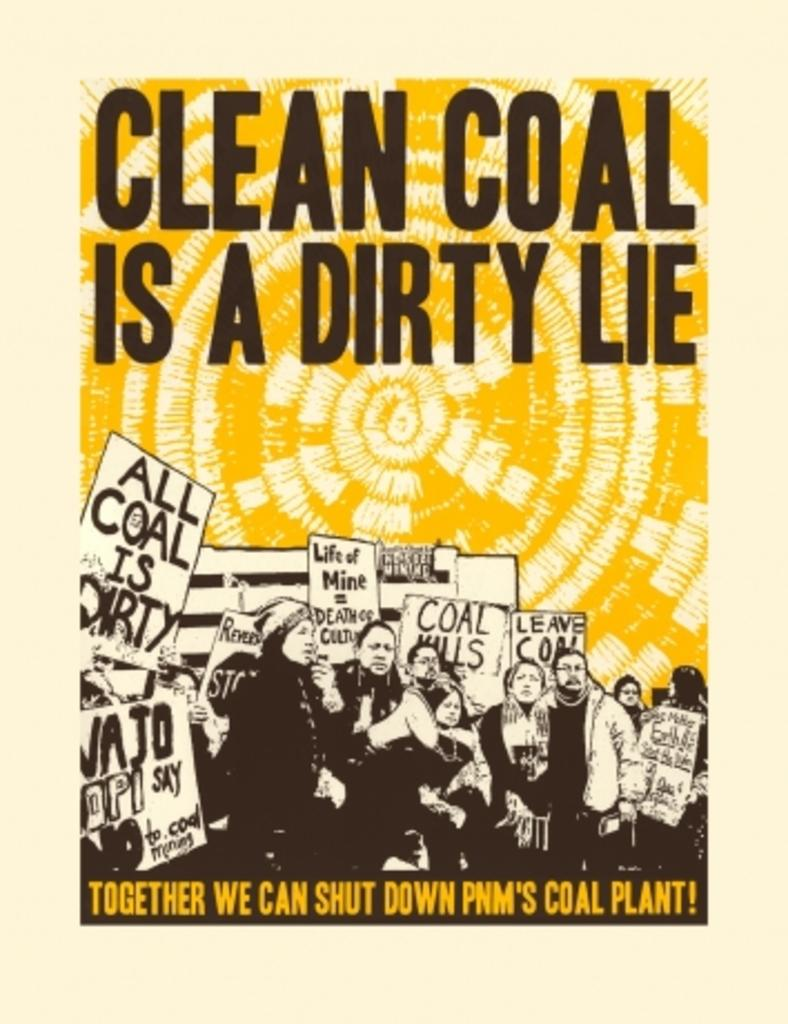<image>
Write a terse but informative summary of the picture. Poster showing people protesting with the phrase "Clean coal is a dirty lie". 